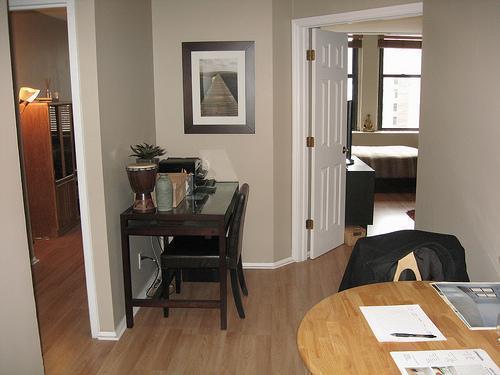How many round tables are there?
Give a very brief answer. 1. How many papers on the table are white?
Give a very brief answer. 2. 